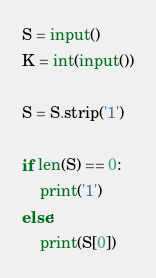<code> <loc_0><loc_0><loc_500><loc_500><_Python_>S = input()
K = int(input())

S = S.strip('1')

if len(S) == 0:
    print('1')
else:
    print(S[0])



</code> 